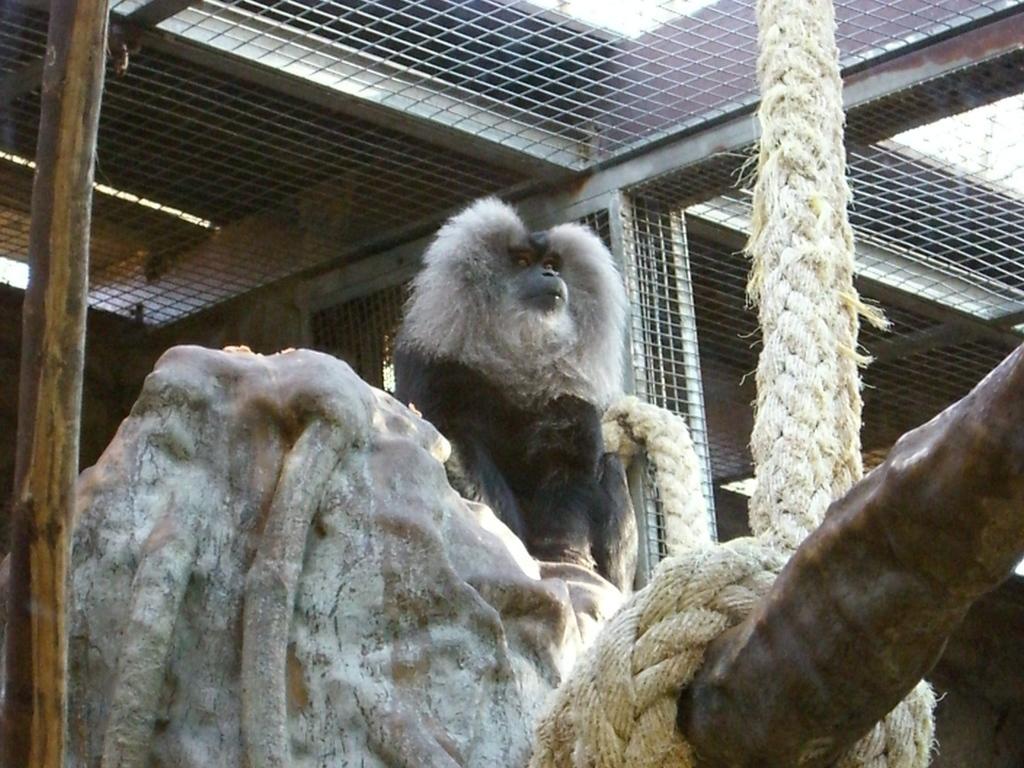Can you describe this image briefly? In this picture there is a black monkey sitting on the rock. In the front there is a white color big rope. On the top we can see the iron cage net. 